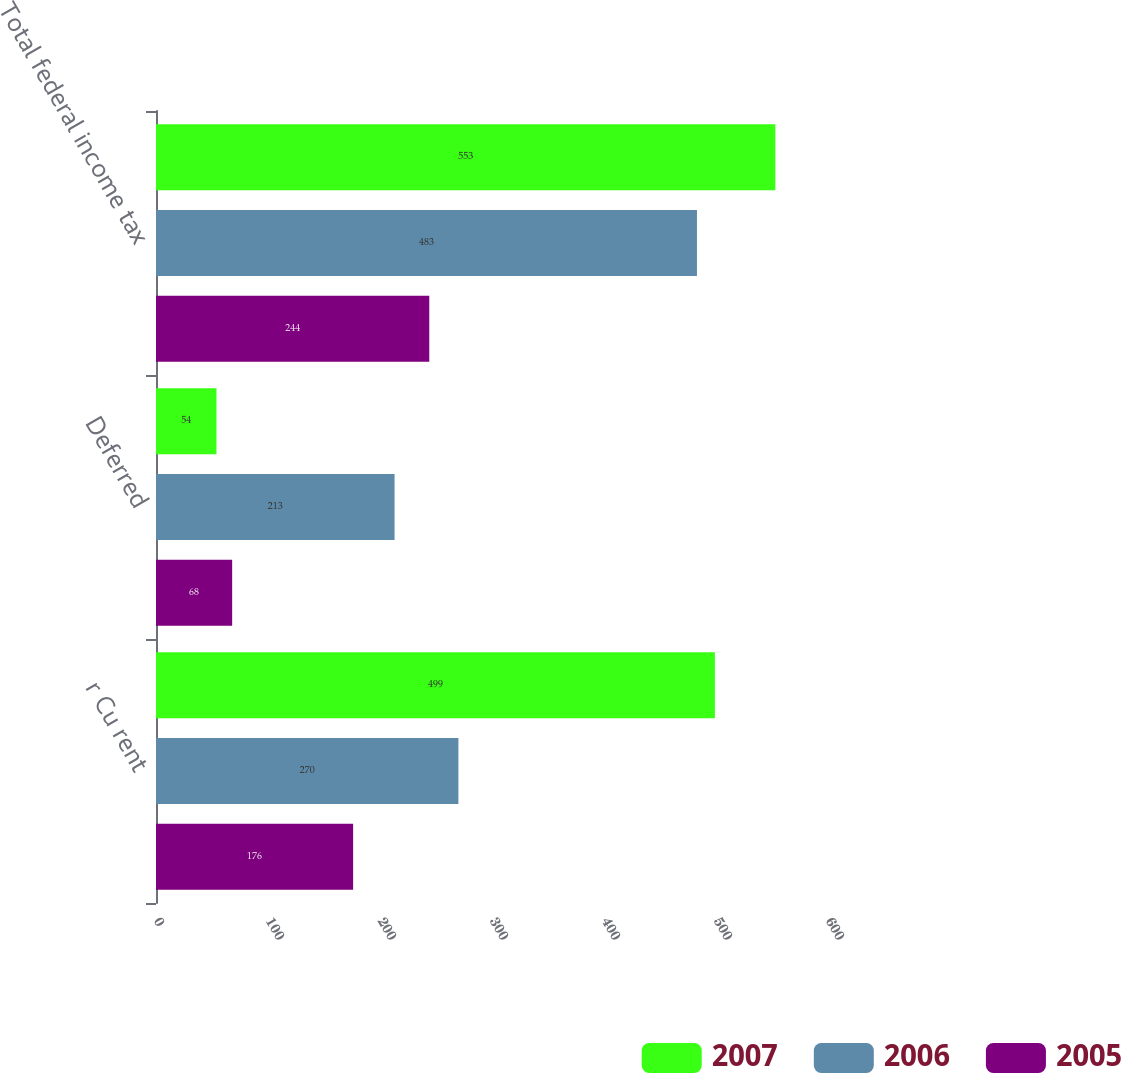<chart> <loc_0><loc_0><loc_500><loc_500><stacked_bar_chart><ecel><fcel>r Cu rent<fcel>Deferred<fcel>Total federal income tax<nl><fcel>2007<fcel>499<fcel>54<fcel>553<nl><fcel>2006<fcel>270<fcel>213<fcel>483<nl><fcel>2005<fcel>176<fcel>68<fcel>244<nl></chart> 